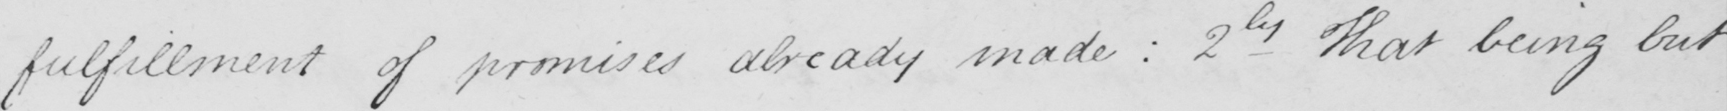Can you tell me what this handwritten text says? fulfillment of promises already made :  2nd That being but 